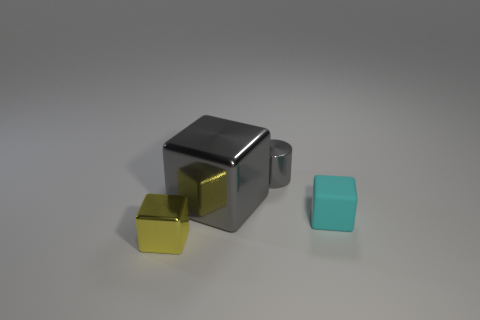Is there any other thing that is the same size as the gray metal block?
Provide a short and direct response. No. What number of big shiny cubes have the same color as the shiny cylinder?
Your answer should be compact. 1. There is a gray thing that is in front of the metallic cylinder; does it have the same size as the gray cylinder?
Make the answer very short. No. There is a tiny thing that is on the left side of the tiny cyan rubber cube and in front of the tiny metallic cylinder; what color is it?
Your answer should be very brief. Yellow. How many things are tiny cyan shiny cubes or tiny objects in front of the big gray shiny object?
Make the answer very short. 2. What material is the tiny cube on the right side of the metallic cube that is behind the block in front of the cyan rubber object?
Provide a short and direct response. Rubber. Is there anything else that has the same material as the small cyan object?
Give a very brief answer. No. Is the color of the metallic object to the right of the gray shiny cube the same as the big metallic block?
Make the answer very short. Yes. What number of gray things are either large metallic cubes or metal cylinders?
Keep it short and to the point. 2. How many other objects are there of the same shape as the tiny gray object?
Ensure brevity in your answer.  0. 